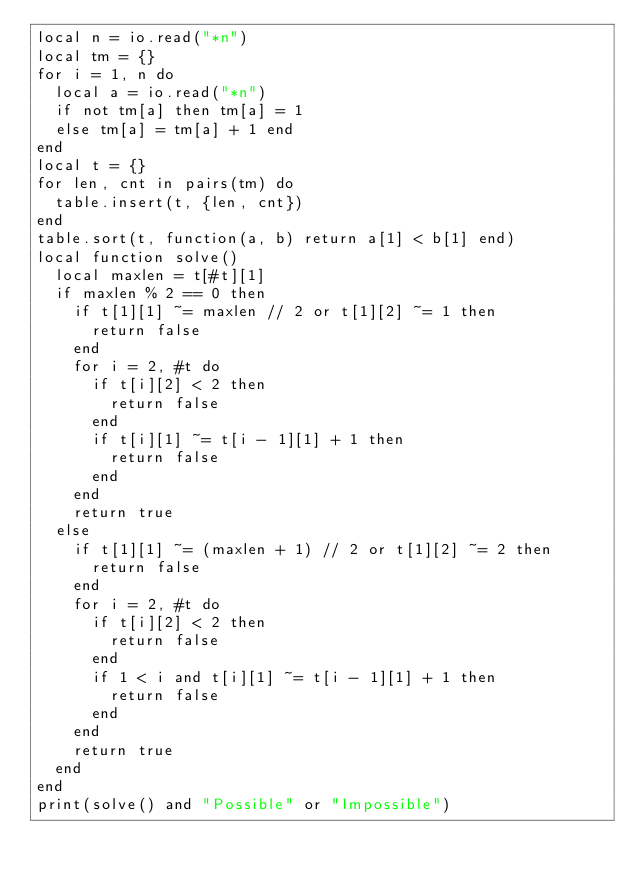<code> <loc_0><loc_0><loc_500><loc_500><_Lua_>local n = io.read("*n")
local tm = {}
for i = 1, n do
  local a = io.read("*n")
  if not tm[a] then tm[a] = 1
  else tm[a] = tm[a] + 1 end
end
local t = {}
for len, cnt in pairs(tm) do
  table.insert(t, {len, cnt})
end
table.sort(t, function(a, b) return a[1] < b[1] end)
local function solve()
  local maxlen = t[#t][1]
  if maxlen % 2 == 0 then
    if t[1][1] ~= maxlen // 2 or t[1][2] ~= 1 then
      return false
    end
    for i = 2, #t do
      if t[i][2] < 2 then
        return false
      end
      if t[i][1] ~= t[i - 1][1] + 1 then
        return false
      end
    end
    return true
  else
    if t[1][1] ~= (maxlen + 1) // 2 or t[1][2] ~= 2 then
      return false
    end
    for i = 2, #t do
      if t[i][2] < 2 then
        return false
      end
      if 1 < i and t[i][1] ~= t[i - 1][1] + 1 then
        return false
      end
    end
    return true
  end
end
print(solve() and "Possible" or "Impossible")
</code> 